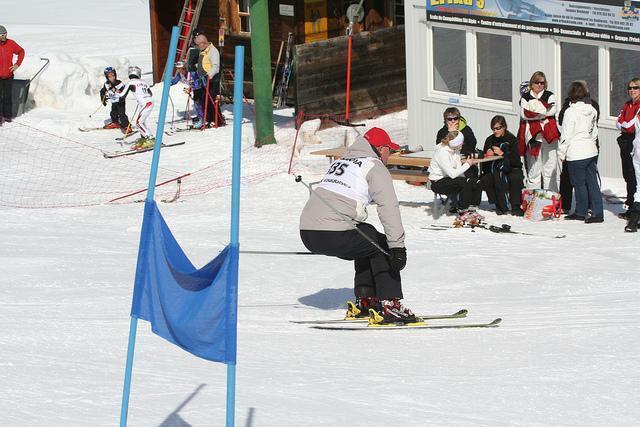How many people are there?
Give a very brief answer. 5. 